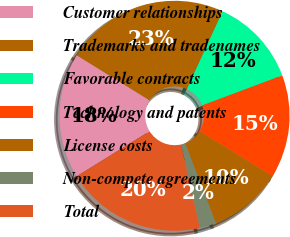Convert chart. <chart><loc_0><loc_0><loc_500><loc_500><pie_chart><fcel>Customer relationships<fcel>Trademarks and tradenames<fcel>Favorable contracts<fcel>Technology and patents<fcel>License costs<fcel>Non-compete agreements<fcel>Total<nl><fcel>17.63%<fcel>23.04%<fcel>12.44%<fcel>14.52%<fcel>10.37%<fcel>2.3%<fcel>19.7%<nl></chart> 